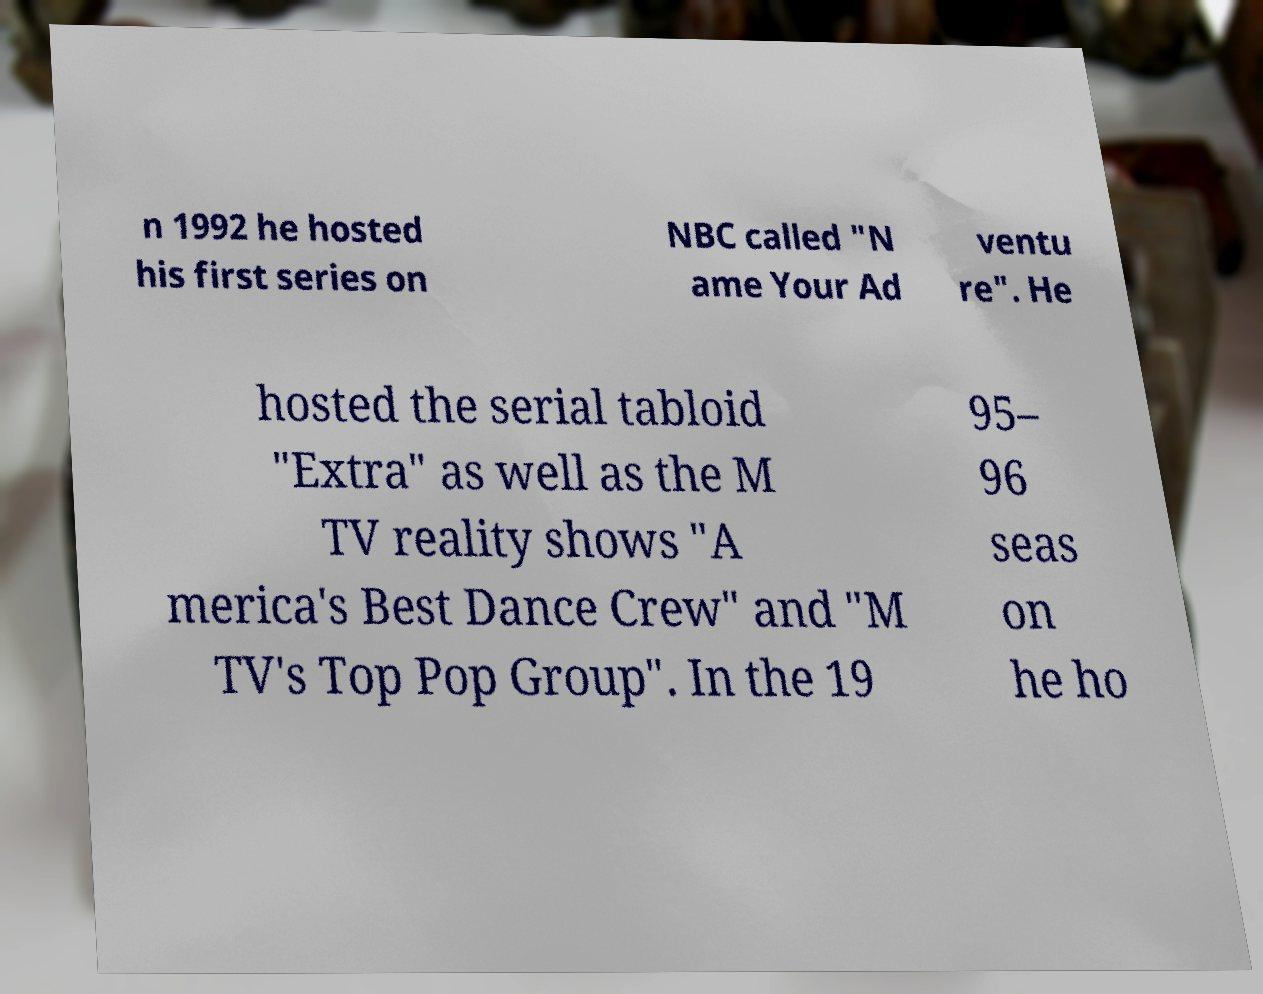Can you read and provide the text displayed in the image?This photo seems to have some interesting text. Can you extract and type it out for me? n 1992 he hosted his first series on NBC called "N ame Your Ad ventu re". He hosted the serial tabloid "Extra" as well as the M TV reality shows "A merica's Best Dance Crew" and "M TV's Top Pop Group". In the 19 95– 96 seas on he ho 